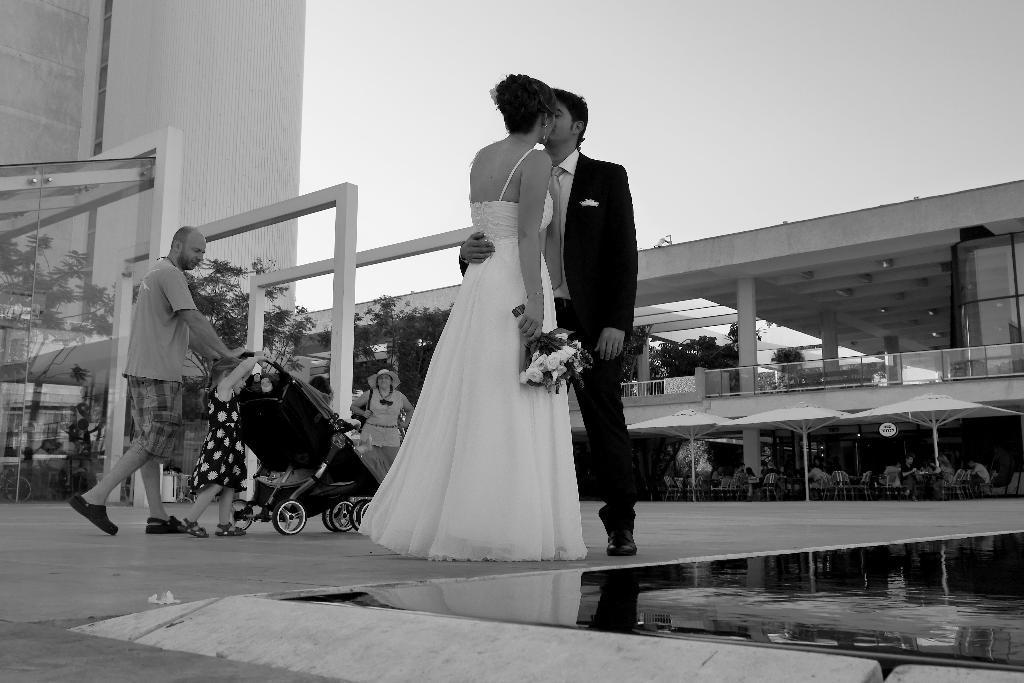Could you give a brief overview of what you see in this image? I see this is a black and white image and I see buildings and I see that this woman and this man are kissing and I see the flowers in her hand and I see few people over here and I can also see the trees and I see few more people on chairs. In the background I see the sky. 